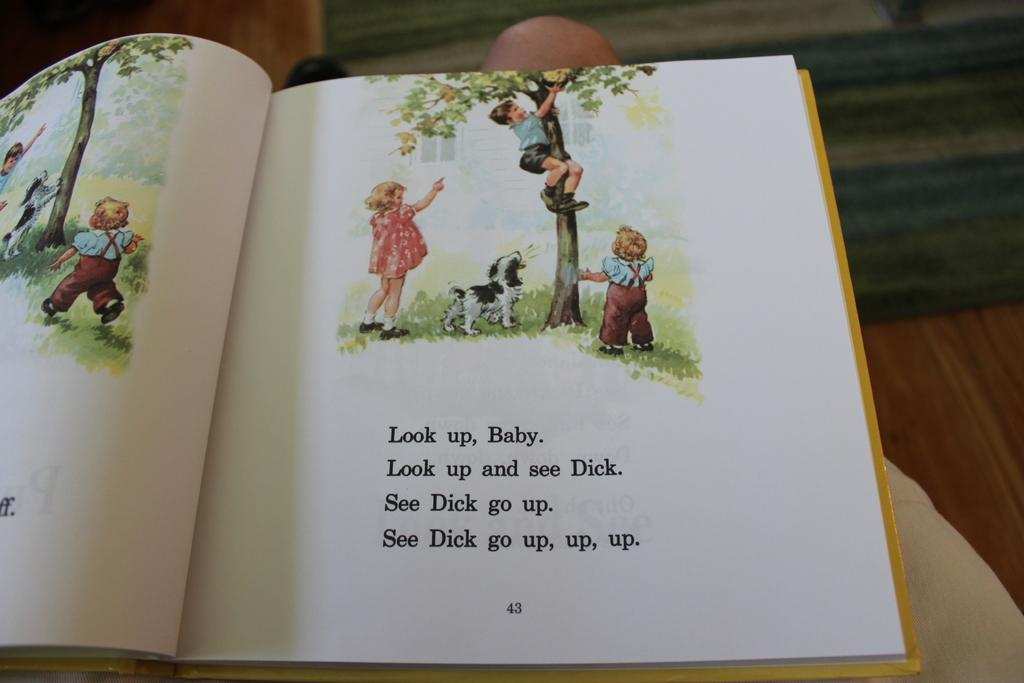<image>
Share a concise interpretation of the image provided. a book that says 'look up, baby' on the page. 